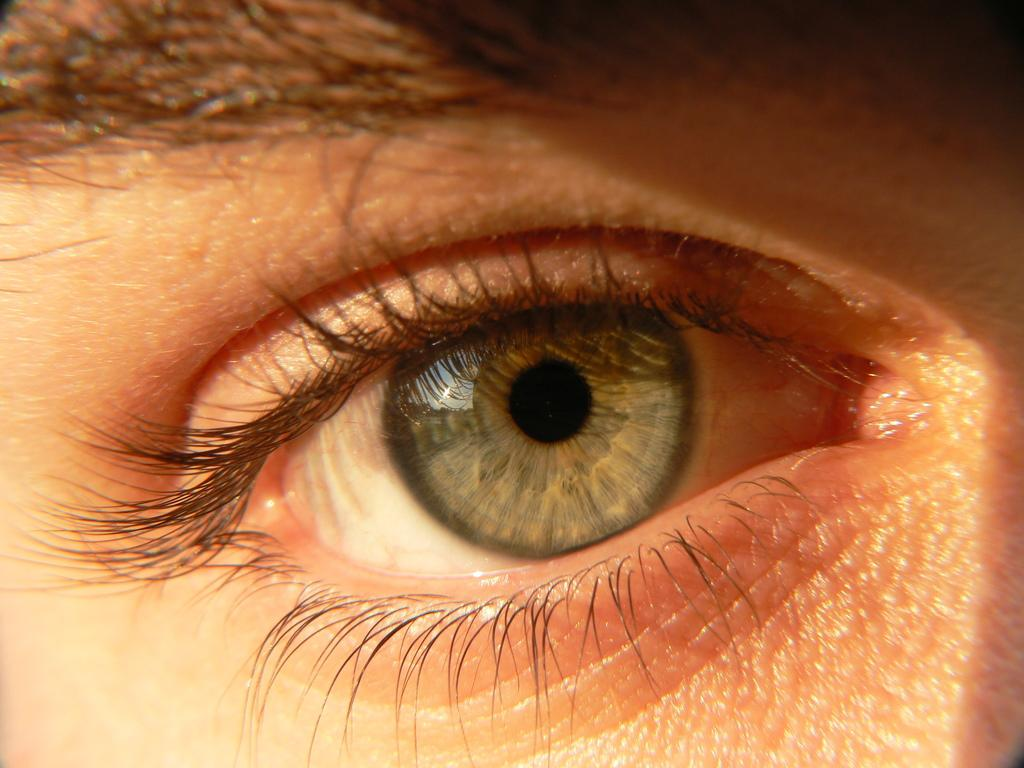What is the main subject in the foreground of the image? There is an eye in the foreground of the image. What parts of the eye are visible in the image? The pupil, iris, and sclera are visible in the eye. What surrounds the eye in the image? Eyelids are present around the eye. What is visible above the eye in the image? The eyebrow is visible above the eye. How many trees can be seen growing on the island in the image? There is no island or trees present in the image; it features an eye with its surrounding features. What type of drum is being played by the person in the image? There is no person or drum present in the image; it features an eye with its surrounding features. 